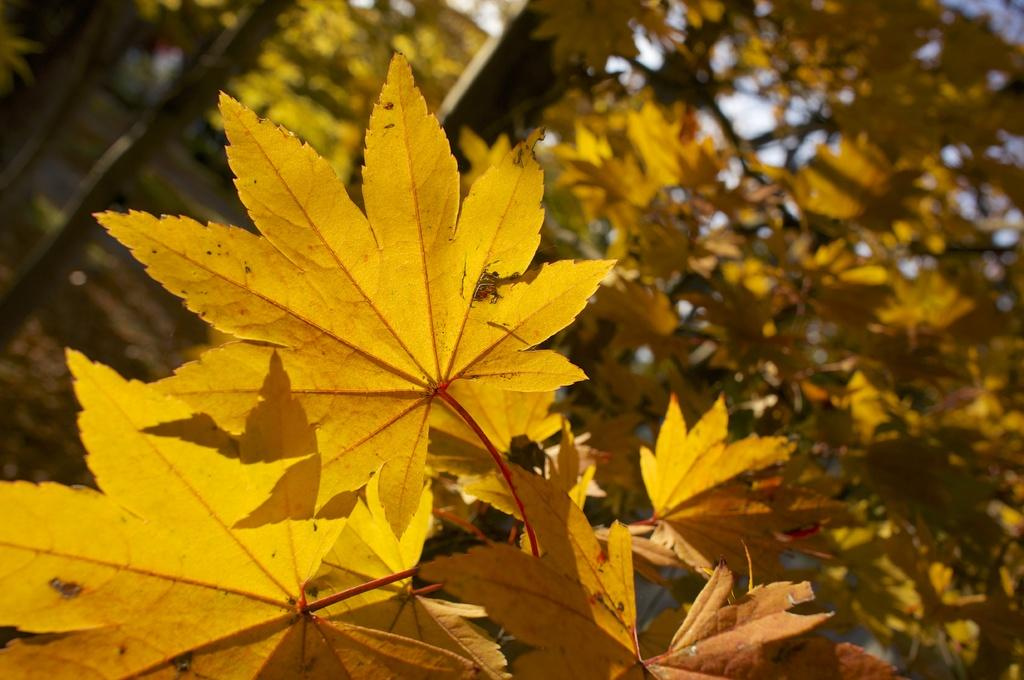What type of vegetation is present in the image? There are leaves in the image. What color are the leaves? The leaves are in yellow color. What can be seen in the background of the image? There is a tree and the sky visible in the background of the image. What type of gun is hidden among the yellow leaves in the image? There is no gun present in the image; it only features yellow leaves and a background with a tree and the sky. 